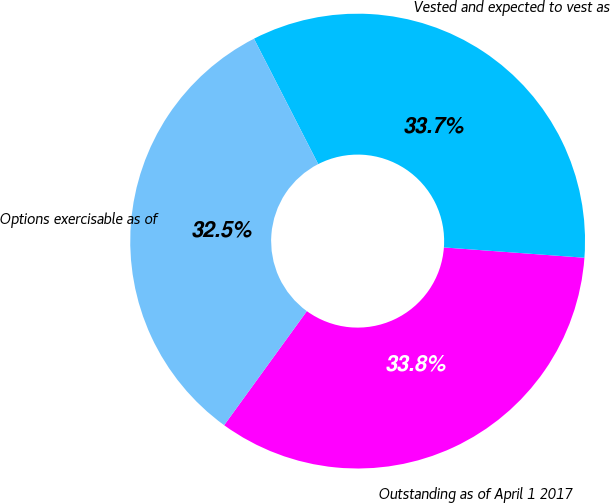<chart> <loc_0><loc_0><loc_500><loc_500><pie_chart><fcel>Outstanding as of April 1 2017<fcel>Vested and expected to vest as<fcel>Options exercisable as of<nl><fcel>33.82%<fcel>33.7%<fcel>32.48%<nl></chart> 